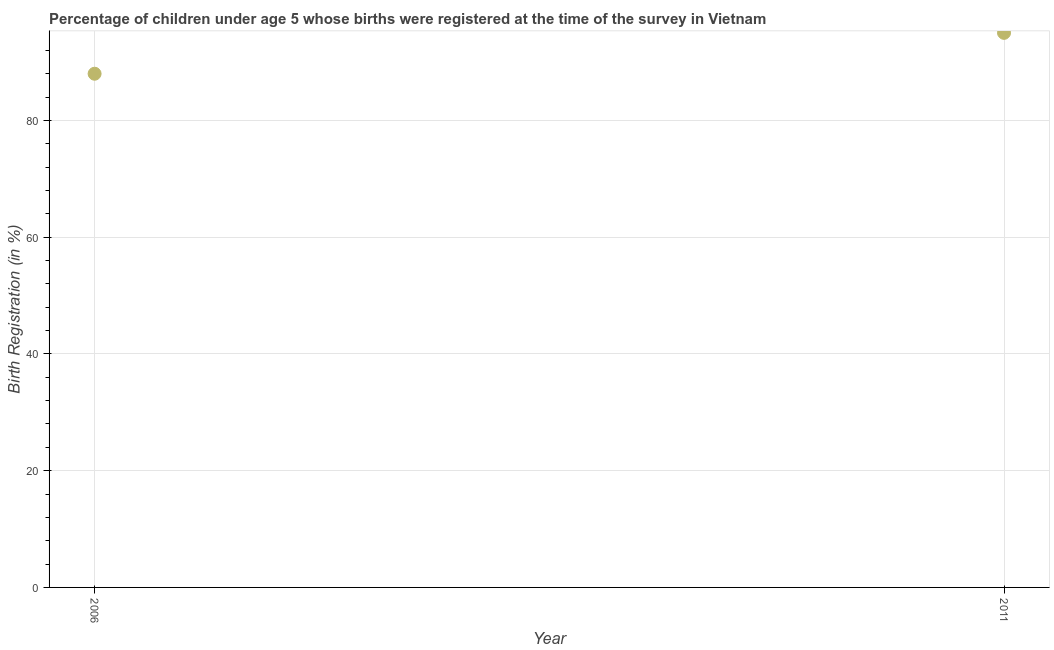What is the birth registration in 2006?
Your response must be concise. 88. Across all years, what is the maximum birth registration?
Give a very brief answer. 95. Across all years, what is the minimum birth registration?
Offer a terse response. 88. In which year was the birth registration maximum?
Keep it short and to the point. 2011. In which year was the birth registration minimum?
Provide a succinct answer. 2006. What is the sum of the birth registration?
Your answer should be compact. 183. What is the difference between the birth registration in 2006 and 2011?
Provide a short and direct response. -7. What is the average birth registration per year?
Offer a very short reply. 91.5. What is the median birth registration?
Ensure brevity in your answer.  91.5. In how many years, is the birth registration greater than 16 %?
Offer a terse response. 2. Do a majority of the years between 2011 and 2006 (inclusive) have birth registration greater than 64 %?
Offer a terse response. No. What is the ratio of the birth registration in 2006 to that in 2011?
Offer a terse response. 0.93. Is the birth registration in 2006 less than that in 2011?
Make the answer very short. Yes. Does the birth registration monotonically increase over the years?
Ensure brevity in your answer.  Yes. How many years are there in the graph?
Your answer should be very brief. 2. What is the difference between two consecutive major ticks on the Y-axis?
Your response must be concise. 20. Are the values on the major ticks of Y-axis written in scientific E-notation?
Give a very brief answer. No. Does the graph contain any zero values?
Offer a terse response. No. What is the title of the graph?
Keep it short and to the point. Percentage of children under age 5 whose births were registered at the time of the survey in Vietnam. What is the label or title of the Y-axis?
Give a very brief answer. Birth Registration (in %). What is the Birth Registration (in %) in 2006?
Make the answer very short. 88. What is the ratio of the Birth Registration (in %) in 2006 to that in 2011?
Your response must be concise. 0.93. 